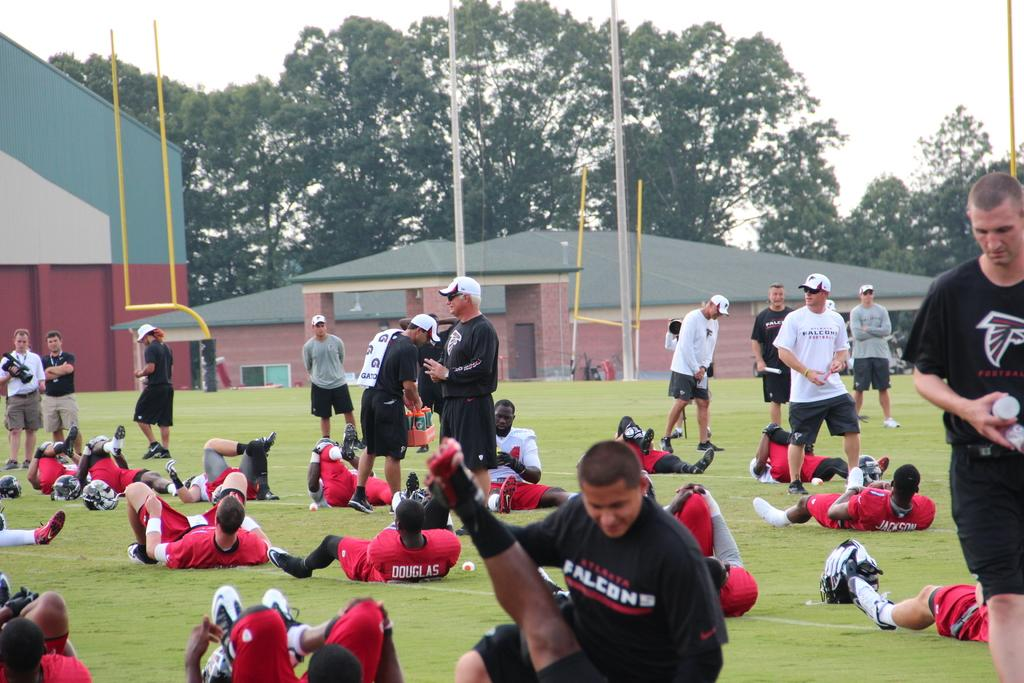Provide a one-sentence caption for the provided image. Group of Falcons football players having practice on a sunny day. 